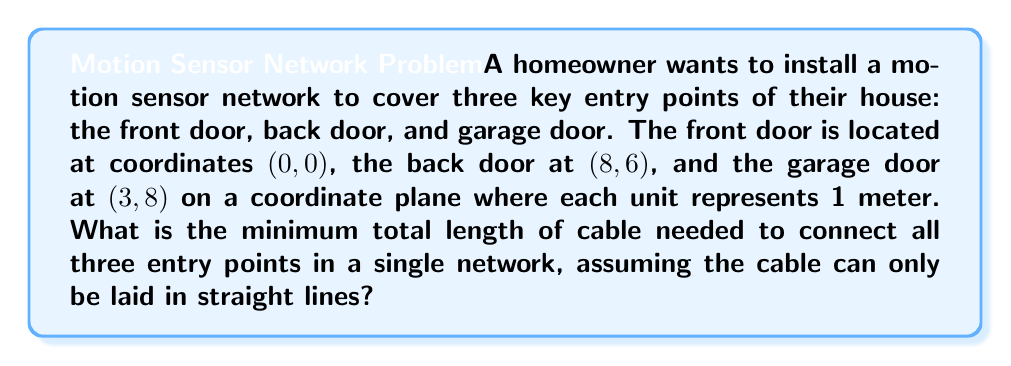Help me with this question. To find the minimum total length of cable needed to connect all three points, we need to determine the shortest path that connects them. This problem is equivalent to finding the minimum spanning tree of the three points, which in this case is the Steiner tree.

Step 1: Visualize the problem
Let's first plot the points on a coordinate plane:

[asy]
unitsize(0.5cm);
defaultpen(fontsize(10pt));

pair A = (0,0);
pair B = (8,6);
pair C = (3,8);

dot("Front door (0,0)", A, SW);
dot("Back door (8,6)", B, SE);
dot("Garage door (3,8)", C, N);

draw(A--B--C--A, dashed);

xaxis(0,10,Arrow);
yaxis(0,10,Arrow);
[/asy]

Step 2: Determine the Steiner point
For three points, the Steiner point (if it exists) forms three 120° angles with the given points. In this case, the Steiner point exists and can be calculated, but the exact coordinates are not necessary for this problem.

Step 3: Check if the Steiner point is beneficial
The Steiner point is beneficial if the largest angle in the triangle formed by the three points is less than 120°. Let's calculate the angles:

Angle at A: $\arccos(\frac{64+9-73}{2\sqrt{64}\sqrt{9}}) \approx 97.13°$
Angle at B: $\arccos(\frac{73+64-9}{2\sqrt{73}\sqrt{64}}) \approx 35.54°$
Angle at C: $\arccos(\frac{73+9-64}{2\sqrt{73}\sqrt{9}}) \approx 47.33°$

Since all angles are less than 120°, the Steiner point is beneficial.

Step 4: Calculate the total length
The total length of the Steiner tree can be calculated using the formula:

$$L = \sqrt{p(p-a)(p-b)(p-c)}$$

where $p = \frac{a+b+c}{2}$ (half-perimeter), and $a$, $b$, and $c$ are the side lengths of the triangle.

$a = \sqrt{8^2 + 6^2} = \sqrt{100} = 10$
$b = \sqrt{3^2 + 8^2} = \sqrt{73}$
$c = \sqrt{8^2 + 2^2} = \sqrt{68}$

$p = \frac{10 + \sqrt{73} + \sqrt{68}}{2}$

Substituting into the formula:

$$L = \sqrt{p(p-10)(p-\sqrt{73})(p-\sqrt{68})}$$

Step 5: Simplify and calculate
The exact value involves complex radicals, so we'll use a calculator to approximate:

$$L \approx 15.96$$

Therefore, the minimum total length of cable needed is approximately 15.96 meters.
Answer: $15.96$ meters 